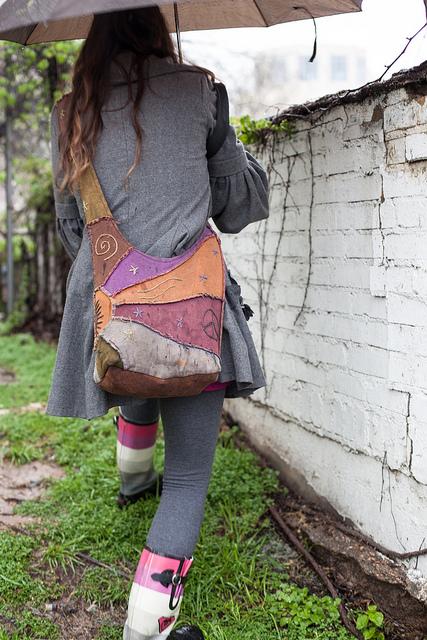Is she carrying a bag in her hand?
Keep it brief. No. What is inside her bag?
Give a very brief answer. Her stuff. What is she wearing?
Write a very short answer. Clothes. 